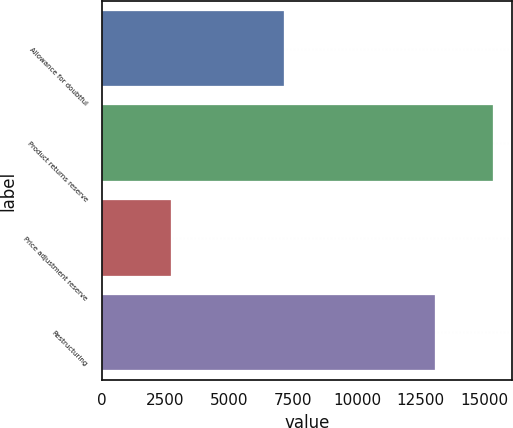Convert chart. <chart><loc_0><loc_0><loc_500><loc_500><bar_chart><fcel>Allowance for doubtful<fcel>Product returns reserve<fcel>Price adjustment reserve<fcel>Restructuring<nl><fcel>7153<fcel>15311<fcel>2702<fcel>13071<nl></chart> 